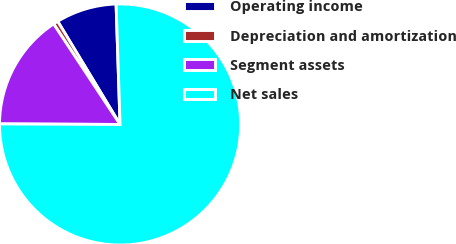<chart> <loc_0><loc_0><loc_500><loc_500><pie_chart><fcel>Operating income<fcel>Depreciation and amortization<fcel>Segment assets<fcel>Net sales<nl><fcel>8.13%<fcel>0.64%<fcel>15.63%<fcel>75.6%<nl></chart> 